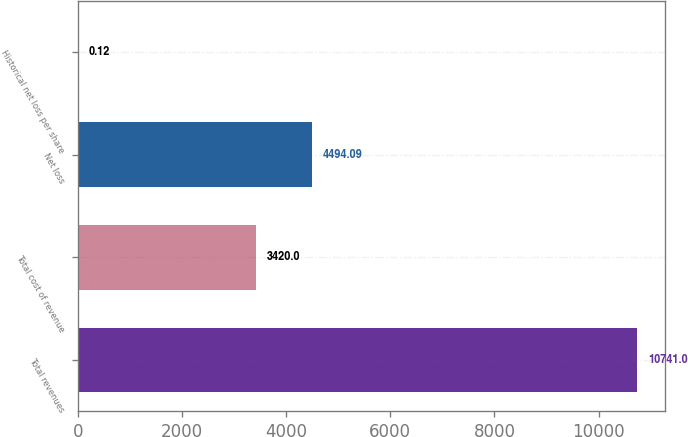Convert chart to OTSL. <chart><loc_0><loc_0><loc_500><loc_500><bar_chart><fcel>Total revenues<fcel>Total cost of revenue<fcel>Net loss<fcel>Historical net loss per share<nl><fcel>10741<fcel>3420<fcel>4494.09<fcel>0.12<nl></chart> 